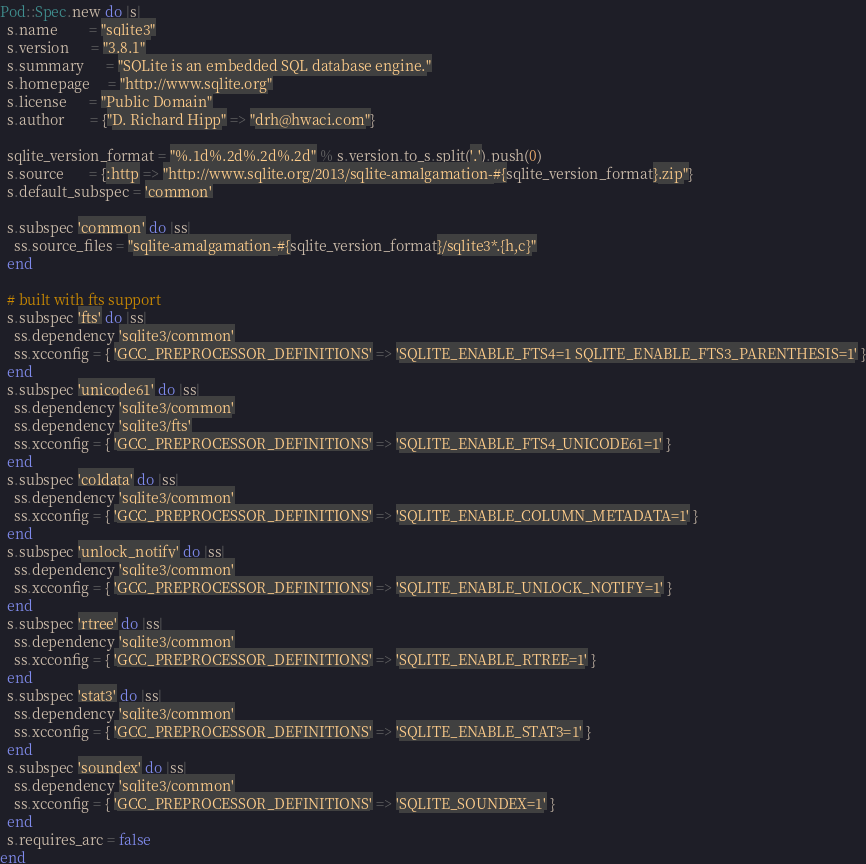Convert code to text. <code><loc_0><loc_0><loc_500><loc_500><_Ruby_>Pod::Spec.new do |s|
  s.name         = "sqlite3"
  s.version      = "3.8.1"
  s.summary      = "SQLite is an embedded SQL database engine."
  s.homepage     = "http://www.sqlite.org"
  s.license      = "Public Domain"
  s.author       = {"D. Richard Hipp" => "drh@hwaci.com"}

  sqlite_version_format = "%.1d%.2d%.2d%.2d" % s.version.to_s.split('.').push(0)
  s.source       = {:http => "http://www.sqlite.org/2013/sqlite-amalgamation-#{sqlite_version_format}.zip"}
  s.default_subspec = 'common'

  s.subspec 'common' do |ss|
    ss.source_files = "sqlite-amalgamation-#{sqlite_version_format}/sqlite3*.{h,c}"
  end

  # built with fts support
  s.subspec 'fts' do |ss|
    ss.dependency 'sqlite3/common'
    ss.xcconfig = { 'GCC_PREPROCESSOR_DEFINITIONS' => 'SQLITE_ENABLE_FTS4=1 SQLITE_ENABLE_FTS3_PARENTHESIS=1' }
  end
  s.subspec 'unicode61' do |ss|
    ss.dependency 'sqlite3/common'
    ss.dependency 'sqlite3/fts'
    ss.xcconfig = { 'GCC_PREPROCESSOR_DEFINITIONS' => 'SQLITE_ENABLE_FTS4_UNICODE61=1' }
  end
  s.subspec 'coldata' do |ss|
    ss.dependency 'sqlite3/common'
    ss.xcconfig = { 'GCC_PREPROCESSOR_DEFINITIONS' => 'SQLITE_ENABLE_COLUMN_METADATA=1' }
  end
  s.subspec 'unlock_notify' do |ss|
    ss.dependency 'sqlite3/common'
    ss.xcconfig = { 'GCC_PREPROCESSOR_DEFINITIONS' => 'SQLITE_ENABLE_UNLOCK_NOTIFY=1' }
  end
  s.subspec 'rtree' do |ss|
    ss.dependency 'sqlite3/common'
    ss.xcconfig = { 'GCC_PREPROCESSOR_DEFINITIONS' => 'SQLITE_ENABLE_RTREE=1' }
  end
  s.subspec 'stat3' do |ss|
    ss.dependency 'sqlite3/common'
    ss.xcconfig = { 'GCC_PREPROCESSOR_DEFINITIONS' => 'SQLITE_ENABLE_STAT3=1' }
  end
  s.subspec 'soundex' do |ss|
    ss.dependency 'sqlite3/common'
    ss.xcconfig = { 'GCC_PREPROCESSOR_DEFINITIONS' => 'SQLITE_SOUNDEX=1' }
  end
  s.requires_arc = false
end
</code> 